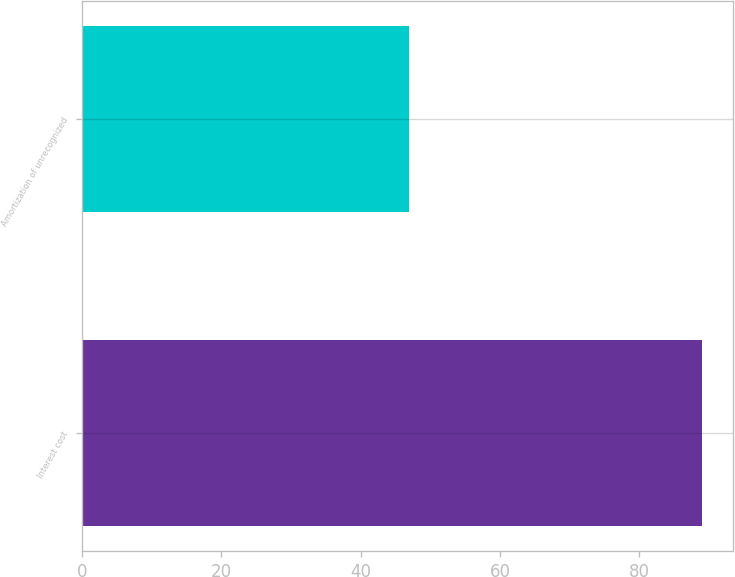<chart> <loc_0><loc_0><loc_500><loc_500><bar_chart><fcel>Interest cost<fcel>Amortization of unrecognized<nl><fcel>89<fcel>47<nl></chart> 